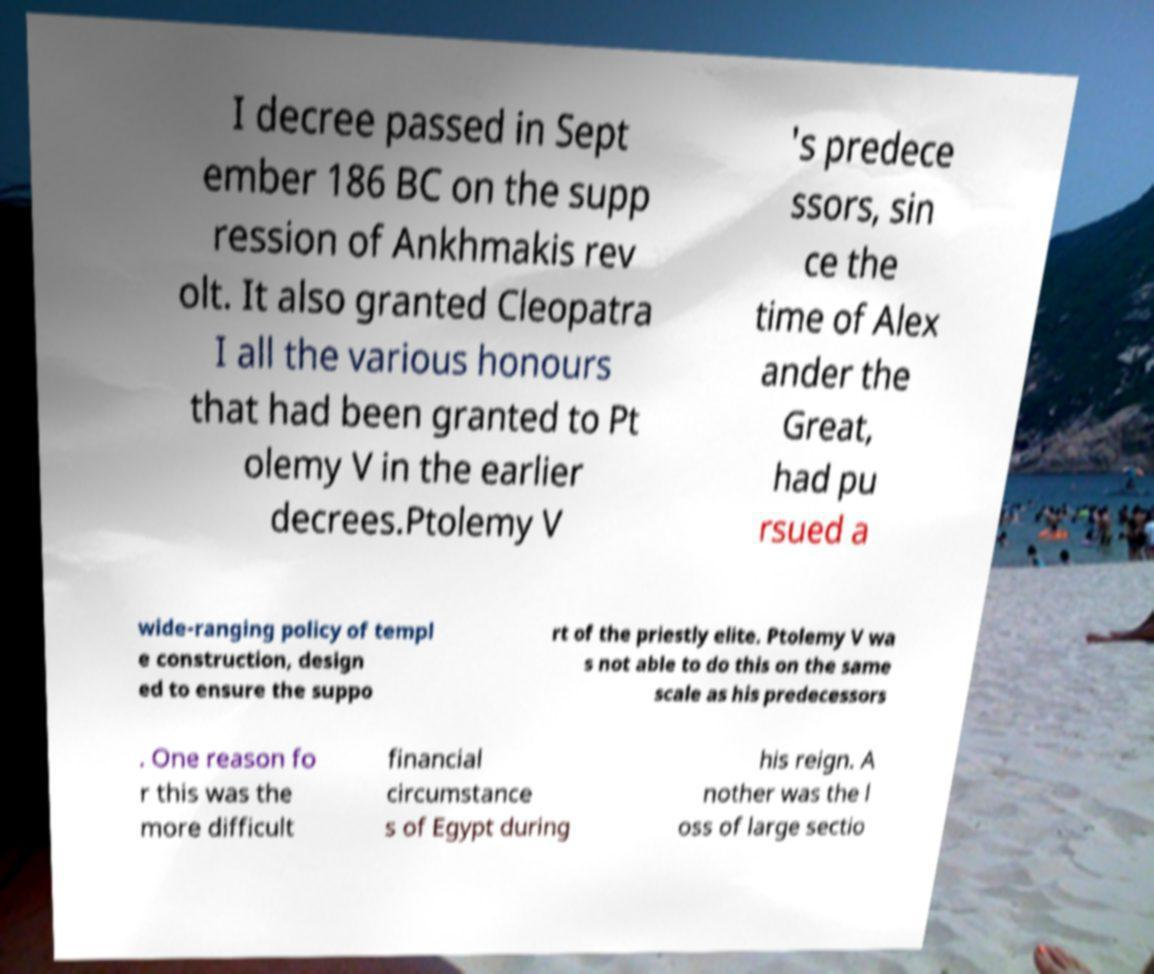Please read and relay the text visible in this image. What does it say? I decree passed in Sept ember 186 BC on the supp ression of Ankhmakis rev olt. It also granted Cleopatra I all the various honours that had been granted to Pt olemy V in the earlier decrees.Ptolemy V 's predece ssors, sin ce the time of Alex ander the Great, had pu rsued a wide-ranging policy of templ e construction, design ed to ensure the suppo rt of the priestly elite. Ptolemy V wa s not able to do this on the same scale as his predecessors . One reason fo r this was the more difficult financial circumstance s of Egypt during his reign. A nother was the l oss of large sectio 